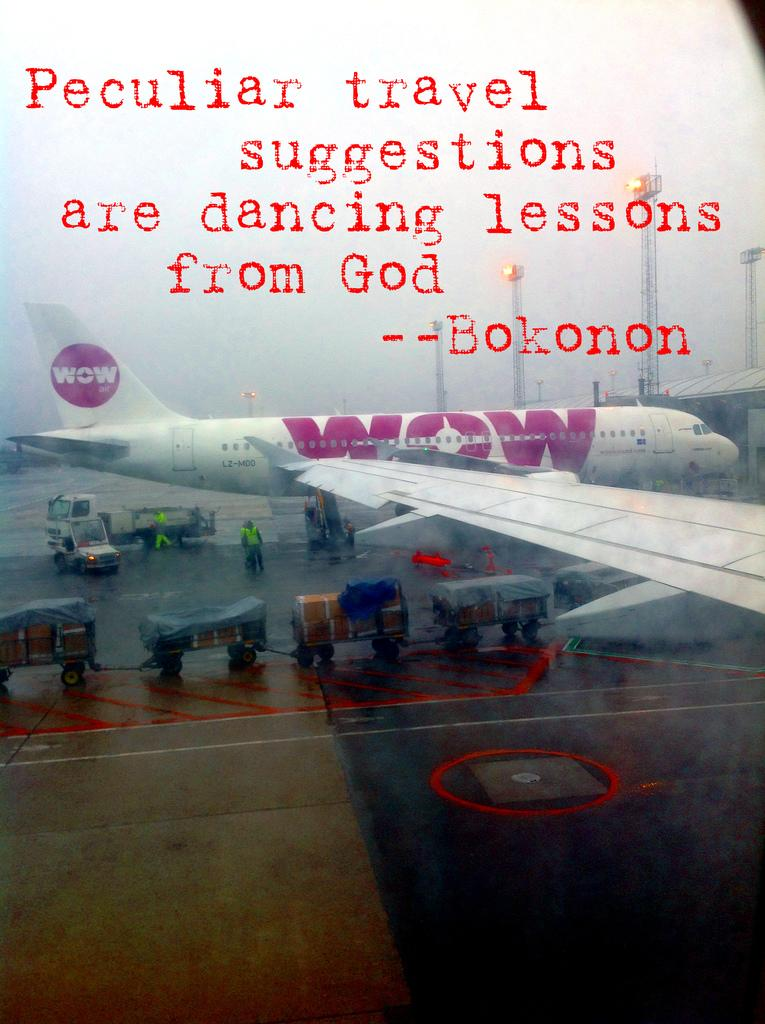Provide a one-sentence caption for the provided image. A WOW plane is being loaded with luggage. 